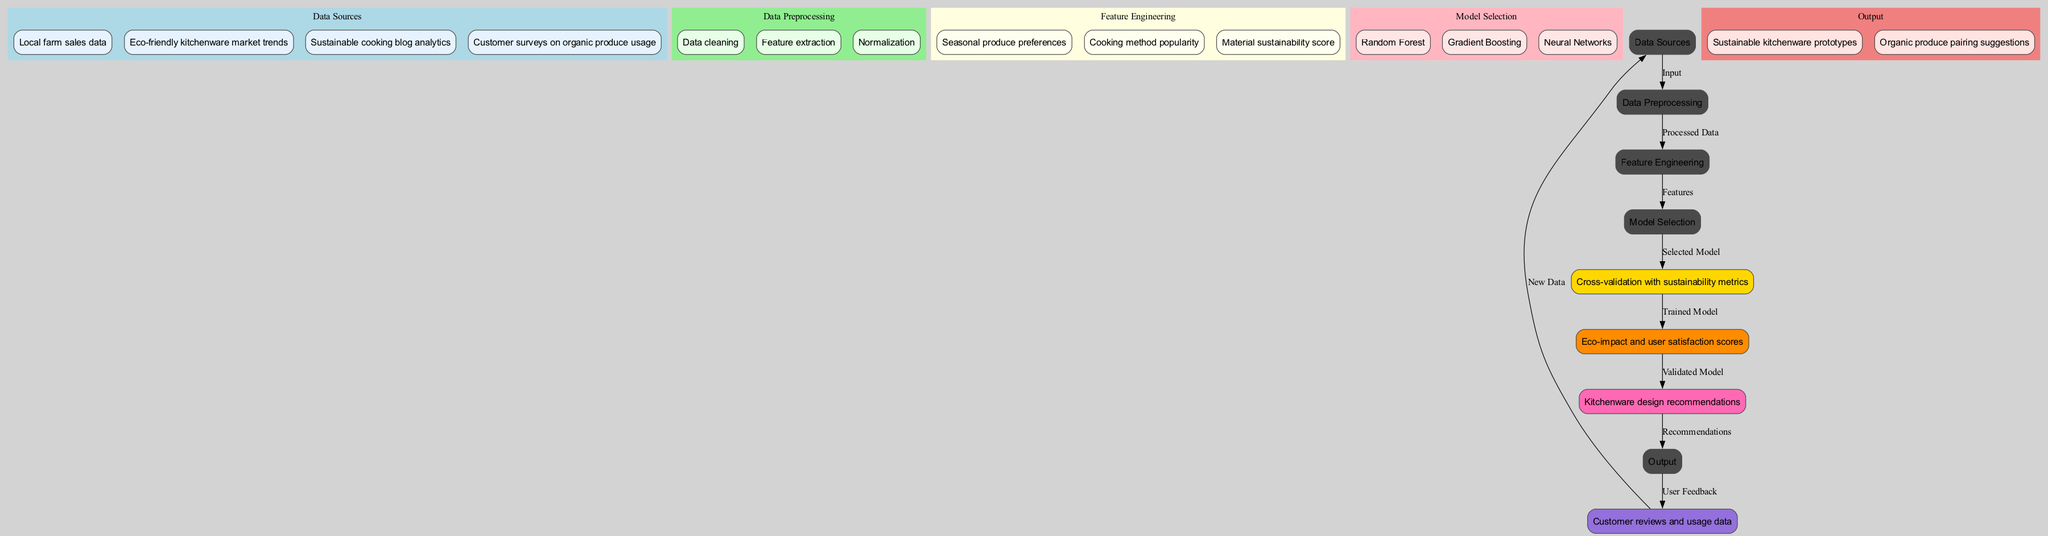What are the data sources used in this diagram? The diagram lists four data sources: Local farm sales data, Eco-friendly kitchenware market trends, Sustainable cooking blog analytics, and Customer surveys on organic produce usage. This can be tracked in the "Data Sources" cluster.
Answer: Local farm sales data, Eco-friendly kitchenware market trends, Sustainable cooking blog analytics, Customer surveys on organic produce usage How many nodes are in the Data Preprocessing section? In the "Data Preprocessing" cluster, there are three steps listed: Data cleaning, Feature extraction, and Normalization. Therefore, the count of nodes in this section is three.
Answer: 3 What is the final output of the machine learning pipeline? The output section specifies two outputs: Sustainable kitchenware prototypes and Organic produce pairing suggestions. This helps identify what the final recommendations are from the machine learning model.
Answer: Sustainable kitchenware prototypes, Organic produce pairing suggestions Which model is selected for training? Among the options listed for model selection, Random Forest, Gradient Boosting, and Neural Networks, the diagram indicates that any of these could be used, so the question implies an understanding that the chosen model will depend on the specific application or results from the previous steps.
Answer: Random Forest, Gradient Boosting, Neural Networks What data flows into the Feedback Loop? The "Feedback Loop" receives data from "Output," indicating the relationship where Customer reviews and usage data provide feedback, creating a continuous improvement cycle for the model. It flows into "Data Sources" as new data feeds back into the system.
Answer: Customer reviews and usage data 